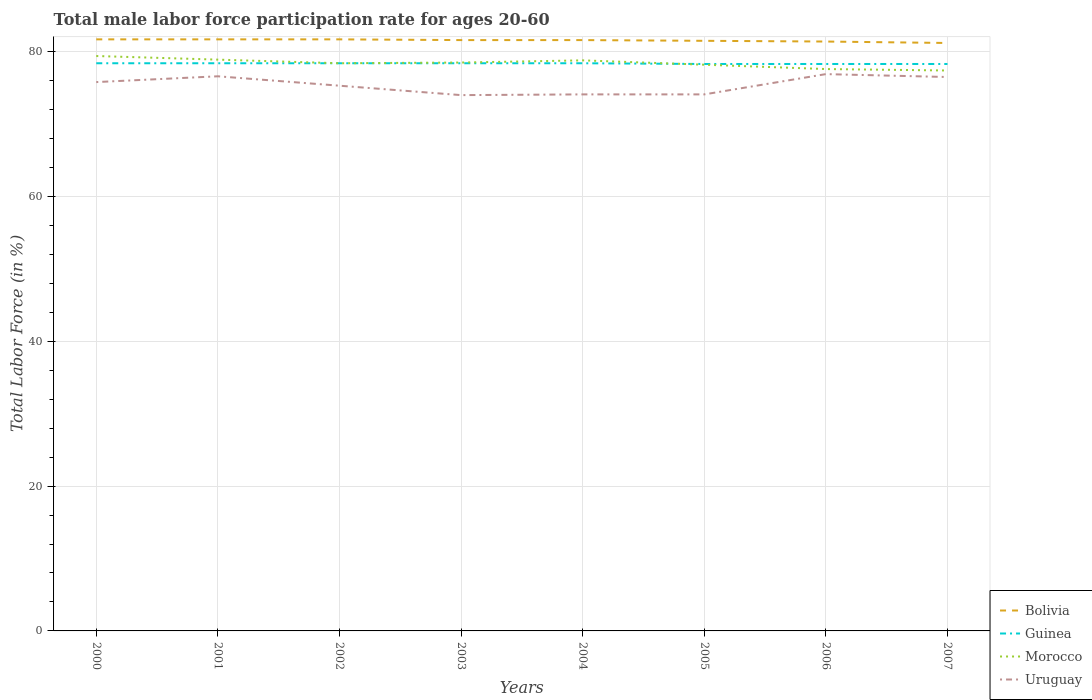How many different coloured lines are there?
Your answer should be compact. 4. Does the line corresponding to Morocco intersect with the line corresponding to Guinea?
Your answer should be compact. Yes. Is the number of lines equal to the number of legend labels?
Offer a very short reply. Yes. In which year was the male labor force participation rate in Uruguay maximum?
Your response must be concise. 2003. What is the total male labor force participation rate in Uruguay in the graph?
Ensure brevity in your answer.  2.5. Is the male labor force participation rate in Morocco strictly greater than the male labor force participation rate in Guinea over the years?
Your response must be concise. No. How many lines are there?
Keep it short and to the point. 4. How many years are there in the graph?
Give a very brief answer. 8. What is the difference between two consecutive major ticks on the Y-axis?
Your response must be concise. 20. Does the graph contain any zero values?
Keep it short and to the point. No. What is the title of the graph?
Your answer should be compact. Total male labor force participation rate for ages 20-60. Does "Montenegro" appear as one of the legend labels in the graph?
Provide a short and direct response. No. What is the label or title of the X-axis?
Provide a succinct answer. Years. What is the label or title of the Y-axis?
Offer a terse response. Total Labor Force (in %). What is the Total Labor Force (in %) of Bolivia in 2000?
Offer a very short reply. 81.7. What is the Total Labor Force (in %) in Guinea in 2000?
Keep it short and to the point. 78.4. What is the Total Labor Force (in %) of Morocco in 2000?
Ensure brevity in your answer.  79.4. What is the Total Labor Force (in %) in Uruguay in 2000?
Keep it short and to the point. 75.8. What is the Total Labor Force (in %) in Bolivia in 2001?
Offer a terse response. 81.7. What is the Total Labor Force (in %) of Guinea in 2001?
Give a very brief answer. 78.4. What is the Total Labor Force (in %) of Morocco in 2001?
Make the answer very short. 78.9. What is the Total Labor Force (in %) of Uruguay in 2001?
Your response must be concise. 76.6. What is the Total Labor Force (in %) of Bolivia in 2002?
Provide a short and direct response. 81.7. What is the Total Labor Force (in %) of Guinea in 2002?
Offer a terse response. 78.4. What is the Total Labor Force (in %) in Morocco in 2002?
Offer a very short reply. 78.4. What is the Total Labor Force (in %) of Uruguay in 2002?
Your answer should be compact. 75.3. What is the Total Labor Force (in %) in Bolivia in 2003?
Your answer should be compact. 81.6. What is the Total Labor Force (in %) in Guinea in 2003?
Make the answer very short. 78.4. What is the Total Labor Force (in %) in Morocco in 2003?
Your answer should be compact. 78.5. What is the Total Labor Force (in %) of Uruguay in 2003?
Your response must be concise. 74. What is the Total Labor Force (in %) of Bolivia in 2004?
Ensure brevity in your answer.  81.6. What is the Total Labor Force (in %) of Guinea in 2004?
Provide a short and direct response. 78.4. What is the Total Labor Force (in %) of Morocco in 2004?
Keep it short and to the point. 78.8. What is the Total Labor Force (in %) of Uruguay in 2004?
Offer a terse response. 74.1. What is the Total Labor Force (in %) in Bolivia in 2005?
Your answer should be very brief. 81.5. What is the Total Labor Force (in %) in Guinea in 2005?
Give a very brief answer. 78.3. What is the Total Labor Force (in %) of Morocco in 2005?
Make the answer very short. 78.2. What is the Total Labor Force (in %) in Uruguay in 2005?
Give a very brief answer. 74.1. What is the Total Labor Force (in %) in Bolivia in 2006?
Offer a very short reply. 81.4. What is the Total Labor Force (in %) in Guinea in 2006?
Give a very brief answer. 78.3. What is the Total Labor Force (in %) in Morocco in 2006?
Keep it short and to the point. 77.6. What is the Total Labor Force (in %) of Uruguay in 2006?
Ensure brevity in your answer.  76.9. What is the Total Labor Force (in %) in Bolivia in 2007?
Ensure brevity in your answer.  81.2. What is the Total Labor Force (in %) in Guinea in 2007?
Ensure brevity in your answer.  78.3. What is the Total Labor Force (in %) in Morocco in 2007?
Provide a short and direct response. 77.4. What is the Total Labor Force (in %) of Uruguay in 2007?
Your answer should be very brief. 76.5. Across all years, what is the maximum Total Labor Force (in %) of Bolivia?
Offer a very short reply. 81.7. Across all years, what is the maximum Total Labor Force (in %) of Guinea?
Offer a terse response. 78.4. Across all years, what is the maximum Total Labor Force (in %) of Morocco?
Provide a succinct answer. 79.4. Across all years, what is the maximum Total Labor Force (in %) in Uruguay?
Ensure brevity in your answer.  76.9. Across all years, what is the minimum Total Labor Force (in %) in Bolivia?
Provide a succinct answer. 81.2. Across all years, what is the minimum Total Labor Force (in %) in Guinea?
Your answer should be compact. 78.3. Across all years, what is the minimum Total Labor Force (in %) in Morocco?
Give a very brief answer. 77.4. What is the total Total Labor Force (in %) of Bolivia in the graph?
Keep it short and to the point. 652.4. What is the total Total Labor Force (in %) in Guinea in the graph?
Your response must be concise. 626.9. What is the total Total Labor Force (in %) of Morocco in the graph?
Your answer should be very brief. 627.2. What is the total Total Labor Force (in %) in Uruguay in the graph?
Provide a short and direct response. 603.3. What is the difference between the Total Labor Force (in %) of Bolivia in 2000 and that in 2001?
Your answer should be compact. 0. What is the difference between the Total Labor Force (in %) in Guinea in 2000 and that in 2001?
Offer a terse response. 0. What is the difference between the Total Labor Force (in %) in Morocco in 2000 and that in 2001?
Your response must be concise. 0.5. What is the difference between the Total Labor Force (in %) in Bolivia in 2000 and that in 2002?
Provide a short and direct response. 0. What is the difference between the Total Labor Force (in %) of Guinea in 2000 and that in 2002?
Offer a very short reply. 0. What is the difference between the Total Labor Force (in %) of Morocco in 2000 and that in 2003?
Give a very brief answer. 0.9. What is the difference between the Total Labor Force (in %) of Uruguay in 2000 and that in 2003?
Your response must be concise. 1.8. What is the difference between the Total Labor Force (in %) of Bolivia in 2000 and that in 2004?
Keep it short and to the point. 0.1. What is the difference between the Total Labor Force (in %) of Bolivia in 2000 and that in 2005?
Your answer should be very brief. 0.2. What is the difference between the Total Labor Force (in %) of Morocco in 2000 and that in 2005?
Ensure brevity in your answer.  1.2. What is the difference between the Total Labor Force (in %) of Guinea in 2000 and that in 2006?
Your answer should be compact. 0.1. What is the difference between the Total Labor Force (in %) in Morocco in 2000 and that in 2006?
Offer a terse response. 1.8. What is the difference between the Total Labor Force (in %) in Uruguay in 2000 and that in 2006?
Your answer should be very brief. -1.1. What is the difference between the Total Labor Force (in %) of Bolivia in 2000 and that in 2007?
Provide a short and direct response. 0.5. What is the difference between the Total Labor Force (in %) in Uruguay in 2000 and that in 2007?
Your answer should be compact. -0.7. What is the difference between the Total Labor Force (in %) of Guinea in 2001 and that in 2002?
Your response must be concise. 0. What is the difference between the Total Labor Force (in %) of Morocco in 2001 and that in 2002?
Provide a short and direct response. 0.5. What is the difference between the Total Labor Force (in %) of Uruguay in 2001 and that in 2002?
Ensure brevity in your answer.  1.3. What is the difference between the Total Labor Force (in %) in Guinea in 2001 and that in 2003?
Ensure brevity in your answer.  0. What is the difference between the Total Labor Force (in %) of Uruguay in 2001 and that in 2003?
Your answer should be compact. 2.6. What is the difference between the Total Labor Force (in %) of Bolivia in 2001 and that in 2004?
Offer a terse response. 0.1. What is the difference between the Total Labor Force (in %) in Morocco in 2001 and that in 2004?
Provide a succinct answer. 0.1. What is the difference between the Total Labor Force (in %) of Bolivia in 2001 and that in 2005?
Make the answer very short. 0.2. What is the difference between the Total Labor Force (in %) in Guinea in 2001 and that in 2005?
Make the answer very short. 0.1. What is the difference between the Total Labor Force (in %) in Morocco in 2001 and that in 2005?
Ensure brevity in your answer.  0.7. What is the difference between the Total Labor Force (in %) of Morocco in 2001 and that in 2006?
Keep it short and to the point. 1.3. What is the difference between the Total Labor Force (in %) of Uruguay in 2001 and that in 2006?
Give a very brief answer. -0.3. What is the difference between the Total Labor Force (in %) in Uruguay in 2001 and that in 2007?
Give a very brief answer. 0.1. What is the difference between the Total Labor Force (in %) in Bolivia in 2002 and that in 2003?
Keep it short and to the point. 0.1. What is the difference between the Total Labor Force (in %) of Morocco in 2002 and that in 2004?
Offer a terse response. -0.4. What is the difference between the Total Labor Force (in %) of Bolivia in 2002 and that in 2005?
Give a very brief answer. 0.2. What is the difference between the Total Labor Force (in %) of Morocco in 2002 and that in 2005?
Provide a short and direct response. 0.2. What is the difference between the Total Labor Force (in %) of Bolivia in 2002 and that in 2006?
Ensure brevity in your answer.  0.3. What is the difference between the Total Labor Force (in %) of Uruguay in 2002 and that in 2006?
Ensure brevity in your answer.  -1.6. What is the difference between the Total Labor Force (in %) of Bolivia in 2002 and that in 2007?
Make the answer very short. 0.5. What is the difference between the Total Labor Force (in %) in Uruguay in 2002 and that in 2007?
Make the answer very short. -1.2. What is the difference between the Total Labor Force (in %) in Guinea in 2003 and that in 2004?
Provide a succinct answer. 0. What is the difference between the Total Labor Force (in %) of Morocco in 2003 and that in 2005?
Provide a succinct answer. 0.3. What is the difference between the Total Labor Force (in %) of Bolivia in 2003 and that in 2006?
Keep it short and to the point. 0.2. What is the difference between the Total Labor Force (in %) of Uruguay in 2003 and that in 2006?
Ensure brevity in your answer.  -2.9. What is the difference between the Total Labor Force (in %) in Morocco in 2003 and that in 2007?
Your response must be concise. 1.1. What is the difference between the Total Labor Force (in %) in Uruguay in 2003 and that in 2007?
Your answer should be very brief. -2.5. What is the difference between the Total Labor Force (in %) of Morocco in 2004 and that in 2005?
Provide a short and direct response. 0.6. What is the difference between the Total Labor Force (in %) of Guinea in 2004 and that in 2006?
Your answer should be compact. 0.1. What is the difference between the Total Labor Force (in %) of Morocco in 2004 and that in 2006?
Ensure brevity in your answer.  1.2. What is the difference between the Total Labor Force (in %) of Bolivia in 2004 and that in 2007?
Provide a short and direct response. 0.4. What is the difference between the Total Labor Force (in %) of Guinea in 2004 and that in 2007?
Keep it short and to the point. 0.1. What is the difference between the Total Labor Force (in %) in Morocco in 2004 and that in 2007?
Your answer should be very brief. 1.4. What is the difference between the Total Labor Force (in %) in Uruguay in 2005 and that in 2006?
Provide a succinct answer. -2.8. What is the difference between the Total Labor Force (in %) of Bolivia in 2005 and that in 2007?
Your answer should be very brief. 0.3. What is the difference between the Total Labor Force (in %) in Morocco in 2006 and that in 2007?
Make the answer very short. 0.2. What is the difference between the Total Labor Force (in %) in Uruguay in 2006 and that in 2007?
Ensure brevity in your answer.  0.4. What is the difference between the Total Labor Force (in %) in Bolivia in 2000 and the Total Labor Force (in %) in Uruguay in 2001?
Offer a terse response. 5.1. What is the difference between the Total Labor Force (in %) in Morocco in 2000 and the Total Labor Force (in %) in Uruguay in 2001?
Provide a short and direct response. 2.8. What is the difference between the Total Labor Force (in %) of Guinea in 2000 and the Total Labor Force (in %) of Morocco in 2002?
Ensure brevity in your answer.  0. What is the difference between the Total Labor Force (in %) in Guinea in 2000 and the Total Labor Force (in %) in Uruguay in 2002?
Your response must be concise. 3.1. What is the difference between the Total Labor Force (in %) of Bolivia in 2000 and the Total Labor Force (in %) of Guinea in 2003?
Offer a terse response. 3.3. What is the difference between the Total Labor Force (in %) in Bolivia in 2000 and the Total Labor Force (in %) in Morocco in 2003?
Your answer should be compact. 3.2. What is the difference between the Total Labor Force (in %) in Bolivia in 2000 and the Total Labor Force (in %) in Morocco in 2004?
Ensure brevity in your answer.  2.9. What is the difference between the Total Labor Force (in %) in Guinea in 2000 and the Total Labor Force (in %) in Morocco in 2004?
Ensure brevity in your answer.  -0.4. What is the difference between the Total Labor Force (in %) in Guinea in 2000 and the Total Labor Force (in %) in Uruguay in 2004?
Make the answer very short. 4.3. What is the difference between the Total Labor Force (in %) in Bolivia in 2000 and the Total Labor Force (in %) in Morocco in 2005?
Provide a succinct answer. 3.5. What is the difference between the Total Labor Force (in %) of Guinea in 2000 and the Total Labor Force (in %) of Morocco in 2005?
Offer a very short reply. 0.2. What is the difference between the Total Labor Force (in %) of Bolivia in 2000 and the Total Labor Force (in %) of Uruguay in 2006?
Give a very brief answer. 4.8. What is the difference between the Total Labor Force (in %) in Guinea in 2000 and the Total Labor Force (in %) in Morocco in 2006?
Offer a terse response. 0.8. What is the difference between the Total Labor Force (in %) of Guinea in 2000 and the Total Labor Force (in %) of Uruguay in 2006?
Ensure brevity in your answer.  1.5. What is the difference between the Total Labor Force (in %) in Morocco in 2000 and the Total Labor Force (in %) in Uruguay in 2006?
Your answer should be compact. 2.5. What is the difference between the Total Labor Force (in %) of Guinea in 2000 and the Total Labor Force (in %) of Morocco in 2007?
Your answer should be very brief. 1. What is the difference between the Total Labor Force (in %) in Guinea in 2000 and the Total Labor Force (in %) in Uruguay in 2007?
Make the answer very short. 1.9. What is the difference between the Total Labor Force (in %) of Morocco in 2000 and the Total Labor Force (in %) of Uruguay in 2007?
Offer a very short reply. 2.9. What is the difference between the Total Labor Force (in %) of Bolivia in 2001 and the Total Labor Force (in %) of Morocco in 2002?
Your response must be concise. 3.3. What is the difference between the Total Labor Force (in %) in Bolivia in 2001 and the Total Labor Force (in %) in Uruguay in 2002?
Keep it short and to the point. 6.4. What is the difference between the Total Labor Force (in %) in Guinea in 2001 and the Total Labor Force (in %) in Morocco in 2002?
Offer a very short reply. 0. What is the difference between the Total Labor Force (in %) in Morocco in 2001 and the Total Labor Force (in %) in Uruguay in 2002?
Your answer should be compact. 3.6. What is the difference between the Total Labor Force (in %) in Bolivia in 2001 and the Total Labor Force (in %) in Morocco in 2003?
Give a very brief answer. 3.2. What is the difference between the Total Labor Force (in %) of Bolivia in 2001 and the Total Labor Force (in %) of Uruguay in 2003?
Your answer should be compact. 7.7. What is the difference between the Total Labor Force (in %) of Guinea in 2001 and the Total Labor Force (in %) of Uruguay in 2003?
Make the answer very short. 4.4. What is the difference between the Total Labor Force (in %) in Bolivia in 2001 and the Total Labor Force (in %) in Morocco in 2004?
Make the answer very short. 2.9. What is the difference between the Total Labor Force (in %) of Bolivia in 2001 and the Total Labor Force (in %) of Uruguay in 2004?
Give a very brief answer. 7.6. What is the difference between the Total Labor Force (in %) of Guinea in 2001 and the Total Labor Force (in %) of Morocco in 2004?
Offer a terse response. -0.4. What is the difference between the Total Labor Force (in %) in Guinea in 2001 and the Total Labor Force (in %) in Uruguay in 2004?
Provide a succinct answer. 4.3. What is the difference between the Total Labor Force (in %) of Bolivia in 2001 and the Total Labor Force (in %) of Guinea in 2005?
Provide a short and direct response. 3.4. What is the difference between the Total Labor Force (in %) of Guinea in 2001 and the Total Labor Force (in %) of Morocco in 2005?
Offer a terse response. 0.2. What is the difference between the Total Labor Force (in %) of Morocco in 2001 and the Total Labor Force (in %) of Uruguay in 2005?
Provide a short and direct response. 4.8. What is the difference between the Total Labor Force (in %) of Bolivia in 2001 and the Total Labor Force (in %) of Guinea in 2006?
Your answer should be compact. 3.4. What is the difference between the Total Labor Force (in %) in Bolivia in 2001 and the Total Labor Force (in %) in Morocco in 2006?
Keep it short and to the point. 4.1. What is the difference between the Total Labor Force (in %) of Bolivia in 2001 and the Total Labor Force (in %) of Uruguay in 2006?
Keep it short and to the point. 4.8. What is the difference between the Total Labor Force (in %) in Bolivia in 2001 and the Total Labor Force (in %) in Guinea in 2007?
Your response must be concise. 3.4. What is the difference between the Total Labor Force (in %) in Bolivia in 2001 and the Total Labor Force (in %) in Uruguay in 2007?
Offer a terse response. 5.2. What is the difference between the Total Labor Force (in %) in Guinea in 2001 and the Total Labor Force (in %) in Morocco in 2007?
Give a very brief answer. 1. What is the difference between the Total Labor Force (in %) in Morocco in 2001 and the Total Labor Force (in %) in Uruguay in 2007?
Give a very brief answer. 2.4. What is the difference between the Total Labor Force (in %) in Bolivia in 2002 and the Total Labor Force (in %) in Guinea in 2003?
Ensure brevity in your answer.  3.3. What is the difference between the Total Labor Force (in %) of Bolivia in 2002 and the Total Labor Force (in %) of Morocco in 2003?
Provide a short and direct response. 3.2. What is the difference between the Total Labor Force (in %) in Guinea in 2002 and the Total Labor Force (in %) in Morocco in 2003?
Your response must be concise. -0.1. What is the difference between the Total Labor Force (in %) in Morocco in 2002 and the Total Labor Force (in %) in Uruguay in 2003?
Keep it short and to the point. 4.4. What is the difference between the Total Labor Force (in %) in Bolivia in 2002 and the Total Labor Force (in %) in Guinea in 2005?
Make the answer very short. 3.4. What is the difference between the Total Labor Force (in %) in Morocco in 2002 and the Total Labor Force (in %) in Uruguay in 2005?
Your answer should be compact. 4.3. What is the difference between the Total Labor Force (in %) of Bolivia in 2002 and the Total Labor Force (in %) of Uruguay in 2006?
Provide a succinct answer. 4.8. What is the difference between the Total Labor Force (in %) in Guinea in 2002 and the Total Labor Force (in %) in Uruguay in 2006?
Give a very brief answer. 1.5. What is the difference between the Total Labor Force (in %) of Bolivia in 2002 and the Total Labor Force (in %) of Guinea in 2007?
Ensure brevity in your answer.  3.4. What is the difference between the Total Labor Force (in %) in Bolivia in 2002 and the Total Labor Force (in %) in Morocco in 2007?
Your answer should be very brief. 4.3. What is the difference between the Total Labor Force (in %) in Bolivia in 2002 and the Total Labor Force (in %) in Uruguay in 2007?
Make the answer very short. 5.2. What is the difference between the Total Labor Force (in %) of Guinea in 2002 and the Total Labor Force (in %) of Uruguay in 2007?
Give a very brief answer. 1.9. What is the difference between the Total Labor Force (in %) in Morocco in 2002 and the Total Labor Force (in %) in Uruguay in 2007?
Your answer should be very brief. 1.9. What is the difference between the Total Labor Force (in %) of Bolivia in 2003 and the Total Labor Force (in %) of Morocco in 2004?
Your answer should be compact. 2.8. What is the difference between the Total Labor Force (in %) of Bolivia in 2003 and the Total Labor Force (in %) of Uruguay in 2004?
Ensure brevity in your answer.  7.5. What is the difference between the Total Labor Force (in %) in Morocco in 2003 and the Total Labor Force (in %) in Uruguay in 2004?
Ensure brevity in your answer.  4.4. What is the difference between the Total Labor Force (in %) of Guinea in 2003 and the Total Labor Force (in %) of Morocco in 2005?
Make the answer very short. 0.2. What is the difference between the Total Labor Force (in %) of Guinea in 2003 and the Total Labor Force (in %) of Uruguay in 2005?
Provide a succinct answer. 4.3. What is the difference between the Total Labor Force (in %) in Morocco in 2003 and the Total Labor Force (in %) in Uruguay in 2005?
Offer a very short reply. 4.4. What is the difference between the Total Labor Force (in %) in Bolivia in 2003 and the Total Labor Force (in %) in Morocco in 2006?
Offer a very short reply. 4. What is the difference between the Total Labor Force (in %) of Bolivia in 2003 and the Total Labor Force (in %) of Uruguay in 2006?
Your answer should be compact. 4.7. What is the difference between the Total Labor Force (in %) in Guinea in 2003 and the Total Labor Force (in %) in Morocco in 2006?
Ensure brevity in your answer.  0.8. What is the difference between the Total Labor Force (in %) in Guinea in 2003 and the Total Labor Force (in %) in Uruguay in 2006?
Provide a short and direct response. 1.5. What is the difference between the Total Labor Force (in %) in Bolivia in 2003 and the Total Labor Force (in %) in Guinea in 2007?
Make the answer very short. 3.3. What is the difference between the Total Labor Force (in %) in Bolivia in 2003 and the Total Labor Force (in %) in Morocco in 2007?
Your response must be concise. 4.2. What is the difference between the Total Labor Force (in %) of Guinea in 2003 and the Total Labor Force (in %) of Morocco in 2007?
Keep it short and to the point. 1. What is the difference between the Total Labor Force (in %) in Guinea in 2003 and the Total Labor Force (in %) in Uruguay in 2007?
Offer a very short reply. 1.9. What is the difference between the Total Labor Force (in %) in Morocco in 2003 and the Total Labor Force (in %) in Uruguay in 2007?
Provide a succinct answer. 2. What is the difference between the Total Labor Force (in %) in Bolivia in 2004 and the Total Labor Force (in %) in Guinea in 2005?
Offer a terse response. 3.3. What is the difference between the Total Labor Force (in %) in Bolivia in 2004 and the Total Labor Force (in %) in Morocco in 2005?
Make the answer very short. 3.4. What is the difference between the Total Labor Force (in %) of Guinea in 2004 and the Total Labor Force (in %) of Uruguay in 2005?
Your response must be concise. 4.3. What is the difference between the Total Labor Force (in %) in Guinea in 2004 and the Total Labor Force (in %) in Morocco in 2006?
Offer a very short reply. 0.8. What is the difference between the Total Labor Force (in %) in Guinea in 2004 and the Total Labor Force (in %) in Morocco in 2007?
Keep it short and to the point. 1. What is the difference between the Total Labor Force (in %) in Morocco in 2004 and the Total Labor Force (in %) in Uruguay in 2007?
Ensure brevity in your answer.  2.3. What is the difference between the Total Labor Force (in %) in Bolivia in 2005 and the Total Labor Force (in %) in Uruguay in 2006?
Offer a very short reply. 4.6. What is the difference between the Total Labor Force (in %) in Morocco in 2005 and the Total Labor Force (in %) in Uruguay in 2006?
Your answer should be compact. 1.3. What is the difference between the Total Labor Force (in %) of Bolivia in 2005 and the Total Labor Force (in %) of Guinea in 2007?
Your answer should be compact. 3.2. What is the difference between the Total Labor Force (in %) of Bolivia in 2005 and the Total Labor Force (in %) of Morocco in 2007?
Your answer should be very brief. 4.1. What is the difference between the Total Labor Force (in %) of Bolivia in 2005 and the Total Labor Force (in %) of Uruguay in 2007?
Your answer should be very brief. 5. What is the difference between the Total Labor Force (in %) in Guinea in 2005 and the Total Labor Force (in %) in Uruguay in 2007?
Provide a succinct answer. 1.8. What is the difference between the Total Labor Force (in %) of Morocco in 2005 and the Total Labor Force (in %) of Uruguay in 2007?
Provide a succinct answer. 1.7. What is the difference between the Total Labor Force (in %) in Bolivia in 2006 and the Total Labor Force (in %) in Guinea in 2007?
Provide a succinct answer. 3.1. What is the difference between the Total Labor Force (in %) in Guinea in 2006 and the Total Labor Force (in %) in Morocco in 2007?
Offer a very short reply. 0.9. What is the difference between the Total Labor Force (in %) in Guinea in 2006 and the Total Labor Force (in %) in Uruguay in 2007?
Ensure brevity in your answer.  1.8. What is the average Total Labor Force (in %) in Bolivia per year?
Your response must be concise. 81.55. What is the average Total Labor Force (in %) in Guinea per year?
Offer a very short reply. 78.36. What is the average Total Labor Force (in %) in Morocco per year?
Provide a short and direct response. 78.4. What is the average Total Labor Force (in %) in Uruguay per year?
Ensure brevity in your answer.  75.41. In the year 2000, what is the difference between the Total Labor Force (in %) of Bolivia and Total Labor Force (in %) of Uruguay?
Keep it short and to the point. 5.9. In the year 2000, what is the difference between the Total Labor Force (in %) in Guinea and Total Labor Force (in %) in Uruguay?
Keep it short and to the point. 2.6. In the year 2001, what is the difference between the Total Labor Force (in %) of Bolivia and Total Labor Force (in %) of Morocco?
Give a very brief answer. 2.8. In the year 2002, what is the difference between the Total Labor Force (in %) in Bolivia and Total Labor Force (in %) in Guinea?
Provide a succinct answer. 3.3. In the year 2002, what is the difference between the Total Labor Force (in %) of Bolivia and Total Labor Force (in %) of Uruguay?
Keep it short and to the point. 6.4. In the year 2002, what is the difference between the Total Labor Force (in %) of Guinea and Total Labor Force (in %) of Morocco?
Your answer should be compact. 0. In the year 2002, what is the difference between the Total Labor Force (in %) in Morocco and Total Labor Force (in %) in Uruguay?
Your answer should be very brief. 3.1. In the year 2003, what is the difference between the Total Labor Force (in %) of Bolivia and Total Labor Force (in %) of Guinea?
Your answer should be very brief. 3.2. In the year 2003, what is the difference between the Total Labor Force (in %) in Morocco and Total Labor Force (in %) in Uruguay?
Keep it short and to the point. 4.5. In the year 2004, what is the difference between the Total Labor Force (in %) in Bolivia and Total Labor Force (in %) in Guinea?
Your answer should be compact. 3.2. In the year 2004, what is the difference between the Total Labor Force (in %) of Bolivia and Total Labor Force (in %) of Morocco?
Keep it short and to the point. 2.8. In the year 2004, what is the difference between the Total Labor Force (in %) of Bolivia and Total Labor Force (in %) of Uruguay?
Ensure brevity in your answer.  7.5. In the year 2004, what is the difference between the Total Labor Force (in %) in Guinea and Total Labor Force (in %) in Morocco?
Keep it short and to the point. -0.4. In the year 2004, what is the difference between the Total Labor Force (in %) in Morocco and Total Labor Force (in %) in Uruguay?
Your answer should be very brief. 4.7. In the year 2005, what is the difference between the Total Labor Force (in %) of Bolivia and Total Labor Force (in %) of Guinea?
Offer a very short reply. 3.2. In the year 2005, what is the difference between the Total Labor Force (in %) in Bolivia and Total Labor Force (in %) in Morocco?
Make the answer very short. 3.3. In the year 2005, what is the difference between the Total Labor Force (in %) in Guinea and Total Labor Force (in %) in Uruguay?
Make the answer very short. 4.2. In the year 2006, what is the difference between the Total Labor Force (in %) in Bolivia and Total Labor Force (in %) in Guinea?
Provide a succinct answer. 3.1. In the year 2006, what is the difference between the Total Labor Force (in %) of Bolivia and Total Labor Force (in %) of Morocco?
Give a very brief answer. 3.8. In the year 2006, what is the difference between the Total Labor Force (in %) in Bolivia and Total Labor Force (in %) in Uruguay?
Give a very brief answer. 4.5. In the year 2006, what is the difference between the Total Labor Force (in %) of Guinea and Total Labor Force (in %) of Morocco?
Provide a short and direct response. 0.7. In the year 2007, what is the difference between the Total Labor Force (in %) in Bolivia and Total Labor Force (in %) in Uruguay?
Make the answer very short. 4.7. In the year 2007, what is the difference between the Total Labor Force (in %) of Guinea and Total Labor Force (in %) of Morocco?
Make the answer very short. 0.9. What is the ratio of the Total Labor Force (in %) of Bolivia in 2000 to that in 2001?
Make the answer very short. 1. What is the ratio of the Total Labor Force (in %) of Guinea in 2000 to that in 2001?
Ensure brevity in your answer.  1. What is the ratio of the Total Labor Force (in %) in Bolivia in 2000 to that in 2002?
Offer a very short reply. 1. What is the ratio of the Total Labor Force (in %) of Morocco in 2000 to that in 2002?
Your answer should be compact. 1.01. What is the ratio of the Total Labor Force (in %) in Uruguay in 2000 to that in 2002?
Offer a very short reply. 1.01. What is the ratio of the Total Labor Force (in %) in Bolivia in 2000 to that in 2003?
Keep it short and to the point. 1. What is the ratio of the Total Labor Force (in %) of Guinea in 2000 to that in 2003?
Ensure brevity in your answer.  1. What is the ratio of the Total Labor Force (in %) of Morocco in 2000 to that in 2003?
Ensure brevity in your answer.  1.01. What is the ratio of the Total Labor Force (in %) of Uruguay in 2000 to that in 2003?
Keep it short and to the point. 1.02. What is the ratio of the Total Labor Force (in %) in Bolivia in 2000 to that in 2004?
Your response must be concise. 1. What is the ratio of the Total Labor Force (in %) of Morocco in 2000 to that in 2004?
Your answer should be compact. 1.01. What is the ratio of the Total Labor Force (in %) in Uruguay in 2000 to that in 2004?
Your answer should be compact. 1.02. What is the ratio of the Total Labor Force (in %) of Bolivia in 2000 to that in 2005?
Make the answer very short. 1. What is the ratio of the Total Labor Force (in %) of Morocco in 2000 to that in 2005?
Offer a terse response. 1.02. What is the ratio of the Total Labor Force (in %) in Uruguay in 2000 to that in 2005?
Offer a terse response. 1.02. What is the ratio of the Total Labor Force (in %) in Bolivia in 2000 to that in 2006?
Your response must be concise. 1. What is the ratio of the Total Labor Force (in %) in Morocco in 2000 to that in 2006?
Provide a succinct answer. 1.02. What is the ratio of the Total Labor Force (in %) of Uruguay in 2000 to that in 2006?
Offer a very short reply. 0.99. What is the ratio of the Total Labor Force (in %) in Bolivia in 2000 to that in 2007?
Give a very brief answer. 1.01. What is the ratio of the Total Labor Force (in %) of Morocco in 2000 to that in 2007?
Make the answer very short. 1.03. What is the ratio of the Total Labor Force (in %) of Bolivia in 2001 to that in 2002?
Make the answer very short. 1. What is the ratio of the Total Labor Force (in %) in Morocco in 2001 to that in 2002?
Provide a short and direct response. 1.01. What is the ratio of the Total Labor Force (in %) in Uruguay in 2001 to that in 2002?
Your response must be concise. 1.02. What is the ratio of the Total Labor Force (in %) of Guinea in 2001 to that in 2003?
Your response must be concise. 1. What is the ratio of the Total Labor Force (in %) in Uruguay in 2001 to that in 2003?
Give a very brief answer. 1.04. What is the ratio of the Total Labor Force (in %) in Guinea in 2001 to that in 2004?
Make the answer very short. 1. What is the ratio of the Total Labor Force (in %) of Morocco in 2001 to that in 2004?
Ensure brevity in your answer.  1. What is the ratio of the Total Labor Force (in %) in Uruguay in 2001 to that in 2004?
Give a very brief answer. 1.03. What is the ratio of the Total Labor Force (in %) in Bolivia in 2001 to that in 2005?
Keep it short and to the point. 1. What is the ratio of the Total Labor Force (in %) in Guinea in 2001 to that in 2005?
Make the answer very short. 1. What is the ratio of the Total Labor Force (in %) in Uruguay in 2001 to that in 2005?
Make the answer very short. 1.03. What is the ratio of the Total Labor Force (in %) in Guinea in 2001 to that in 2006?
Provide a succinct answer. 1. What is the ratio of the Total Labor Force (in %) in Morocco in 2001 to that in 2006?
Give a very brief answer. 1.02. What is the ratio of the Total Labor Force (in %) in Guinea in 2001 to that in 2007?
Provide a short and direct response. 1. What is the ratio of the Total Labor Force (in %) in Morocco in 2001 to that in 2007?
Offer a terse response. 1.02. What is the ratio of the Total Labor Force (in %) in Uruguay in 2001 to that in 2007?
Make the answer very short. 1. What is the ratio of the Total Labor Force (in %) in Guinea in 2002 to that in 2003?
Provide a succinct answer. 1. What is the ratio of the Total Labor Force (in %) of Uruguay in 2002 to that in 2003?
Make the answer very short. 1.02. What is the ratio of the Total Labor Force (in %) in Uruguay in 2002 to that in 2004?
Your answer should be very brief. 1.02. What is the ratio of the Total Labor Force (in %) in Bolivia in 2002 to that in 2005?
Provide a short and direct response. 1. What is the ratio of the Total Labor Force (in %) of Uruguay in 2002 to that in 2005?
Keep it short and to the point. 1.02. What is the ratio of the Total Labor Force (in %) of Bolivia in 2002 to that in 2006?
Ensure brevity in your answer.  1. What is the ratio of the Total Labor Force (in %) of Guinea in 2002 to that in 2006?
Your answer should be compact. 1. What is the ratio of the Total Labor Force (in %) of Morocco in 2002 to that in 2006?
Offer a very short reply. 1.01. What is the ratio of the Total Labor Force (in %) in Uruguay in 2002 to that in 2006?
Your answer should be compact. 0.98. What is the ratio of the Total Labor Force (in %) of Guinea in 2002 to that in 2007?
Your answer should be compact. 1. What is the ratio of the Total Labor Force (in %) in Morocco in 2002 to that in 2007?
Provide a short and direct response. 1.01. What is the ratio of the Total Labor Force (in %) of Uruguay in 2002 to that in 2007?
Offer a very short reply. 0.98. What is the ratio of the Total Labor Force (in %) of Morocco in 2003 to that in 2004?
Give a very brief answer. 1. What is the ratio of the Total Labor Force (in %) of Uruguay in 2003 to that in 2005?
Make the answer very short. 1. What is the ratio of the Total Labor Force (in %) of Guinea in 2003 to that in 2006?
Your answer should be very brief. 1. What is the ratio of the Total Labor Force (in %) in Morocco in 2003 to that in 2006?
Give a very brief answer. 1.01. What is the ratio of the Total Labor Force (in %) of Uruguay in 2003 to that in 2006?
Give a very brief answer. 0.96. What is the ratio of the Total Labor Force (in %) in Bolivia in 2003 to that in 2007?
Your response must be concise. 1. What is the ratio of the Total Labor Force (in %) of Morocco in 2003 to that in 2007?
Make the answer very short. 1.01. What is the ratio of the Total Labor Force (in %) in Uruguay in 2003 to that in 2007?
Offer a very short reply. 0.97. What is the ratio of the Total Labor Force (in %) of Bolivia in 2004 to that in 2005?
Provide a short and direct response. 1. What is the ratio of the Total Labor Force (in %) in Morocco in 2004 to that in 2005?
Offer a terse response. 1.01. What is the ratio of the Total Labor Force (in %) of Uruguay in 2004 to that in 2005?
Provide a succinct answer. 1. What is the ratio of the Total Labor Force (in %) of Bolivia in 2004 to that in 2006?
Make the answer very short. 1. What is the ratio of the Total Labor Force (in %) in Guinea in 2004 to that in 2006?
Provide a succinct answer. 1. What is the ratio of the Total Labor Force (in %) in Morocco in 2004 to that in 2006?
Ensure brevity in your answer.  1.02. What is the ratio of the Total Labor Force (in %) of Uruguay in 2004 to that in 2006?
Make the answer very short. 0.96. What is the ratio of the Total Labor Force (in %) of Bolivia in 2004 to that in 2007?
Offer a terse response. 1. What is the ratio of the Total Labor Force (in %) in Morocco in 2004 to that in 2007?
Provide a succinct answer. 1.02. What is the ratio of the Total Labor Force (in %) in Uruguay in 2004 to that in 2007?
Keep it short and to the point. 0.97. What is the ratio of the Total Labor Force (in %) in Bolivia in 2005 to that in 2006?
Ensure brevity in your answer.  1. What is the ratio of the Total Labor Force (in %) in Guinea in 2005 to that in 2006?
Offer a very short reply. 1. What is the ratio of the Total Labor Force (in %) of Morocco in 2005 to that in 2006?
Keep it short and to the point. 1.01. What is the ratio of the Total Labor Force (in %) in Uruguay in 2005 to that in 2006?
Provide a short and direct response. 0.96. What is the ratio of the Total Labor Force (in %) of Morocco in 2005 to that in 2007?
Your answer should be very brief. 1.01. What is the ratio of the Total Labor Force (in %) in Uruguay in 2005 to that in 2007?
Your answer should be very brief. 0.97. What is the ratio of the Total Labor Force (in %) of Morocco in 2006 to that in 2007?
Your answer should be very brief. 1. What is the ratio of the Total Labor Force (in %) of Uruguay in 2006 to that in 2007?
Make the answer very short. 1.01. What is the difference between the highest and the second highest Total Labor Force (in %) in Bolivia?
Offer a very short reply. 0. What is the difference between the highest and the second highest Total Labor Force (in %) in Guinea?
Offer a very short reply. 0. What is the difference between the highest and the lowest Total Labor Force (in %) of Guinea?
Your response must be concise. 0.1. What is the difference between the highest and the lowest Total Labor Force (in %) of Uruguay?
Offer a very short reply. 2.9. 